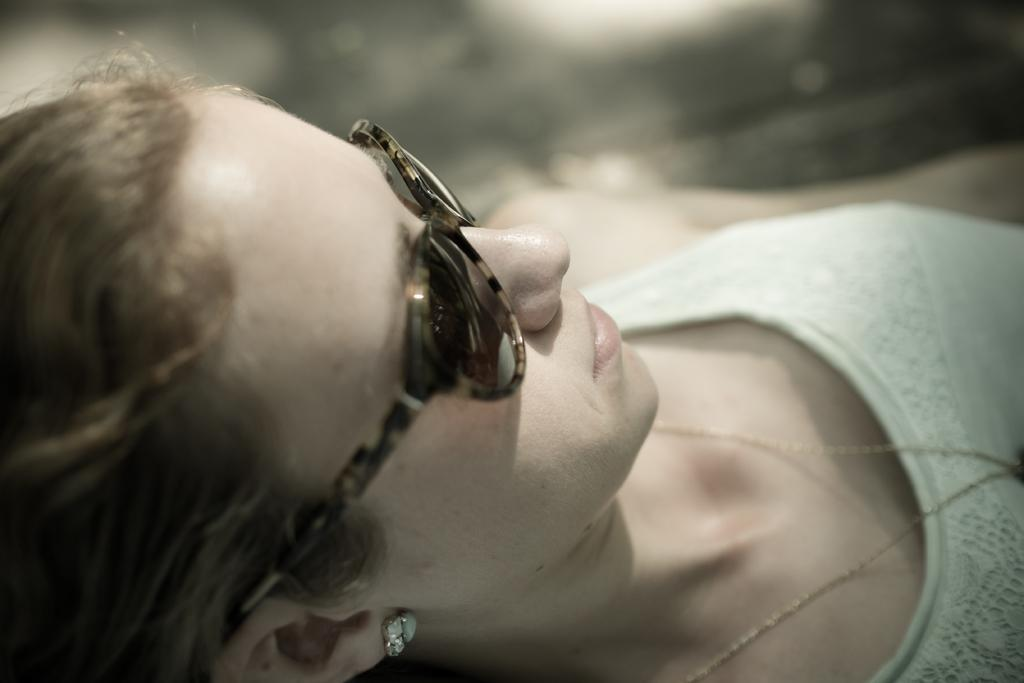Who is present in the image? There is a woman in the image. What is the woman wearing on her face? The woman is wearing goggles in the image. What type of humor can be seen in the woman's mouth in the image? There is no humor or mouth visible in the image; the woman is wearing goggles. 